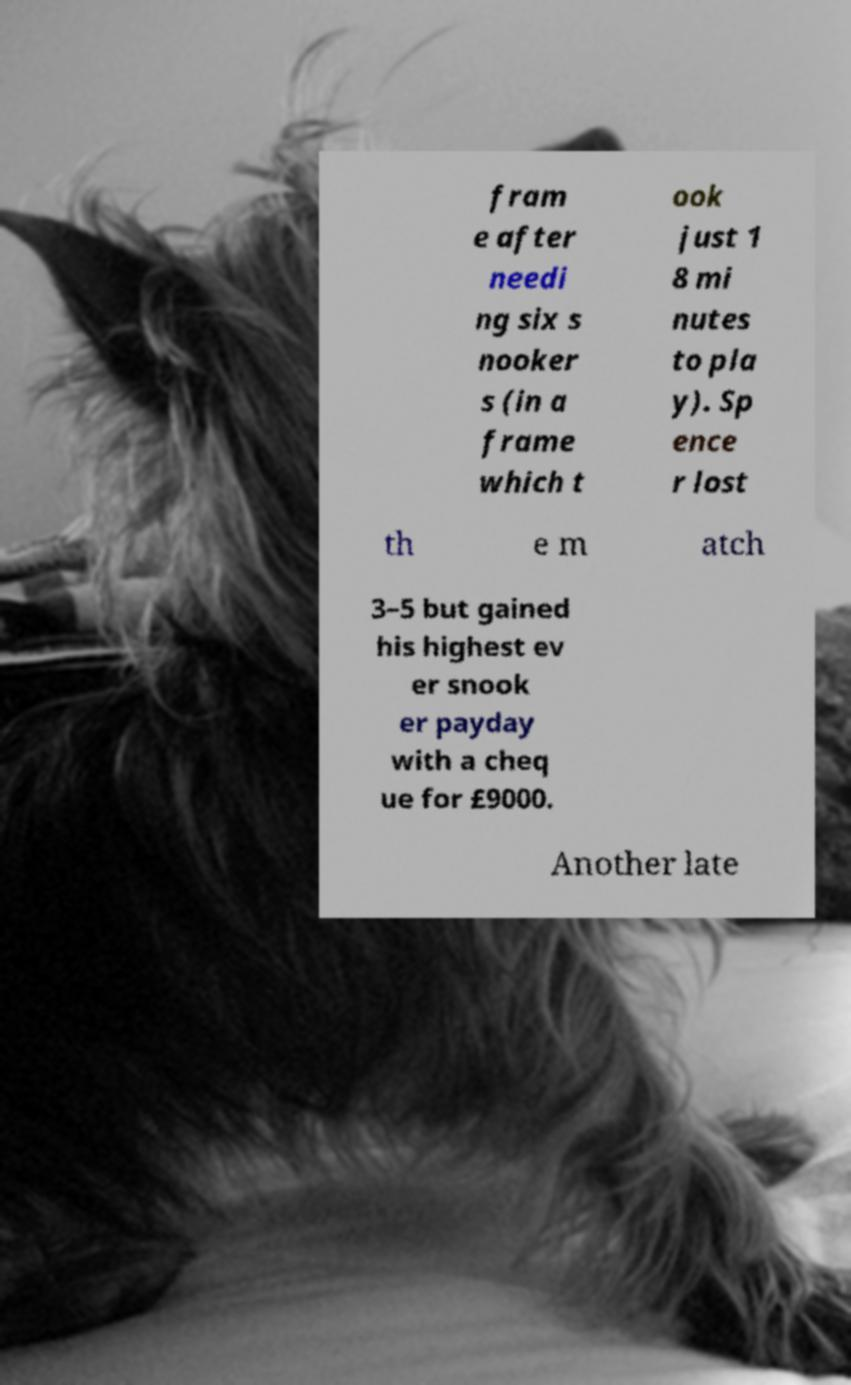I need the written content from this picture converted into text. Can you do that? fram e after needi ng six s nooker s (in a frame which t ook just 1 8 mi nutes to pla y). Sp ence r lost th e m atch 3–5 but gained his highest ev er snook er payday with a cheq ue for £9000. Another late 